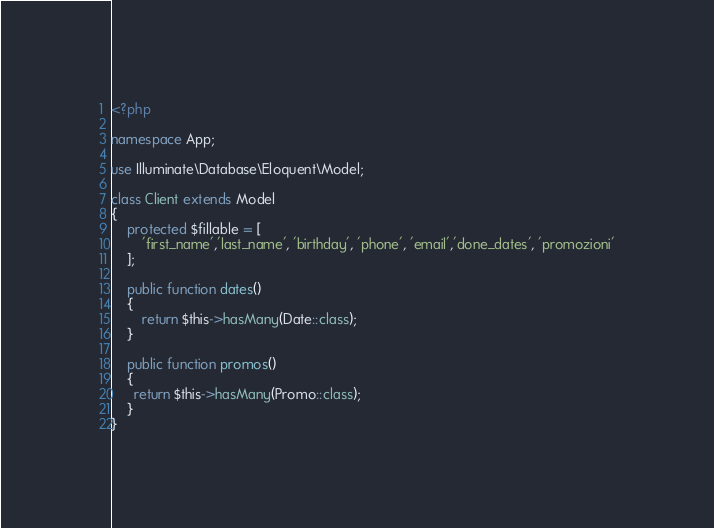Convert code to text. <code><loc_0><loc_0><loc_500><loc_500><_PHP_><?php

namespace App;

use Illuminate\Database\Eloquent\Model;

class Client extends Model
{
    protected $fillable = [
    	'first_name','last_name', 'birthday', 'phone', 'email','done_dates', 'promozioni'
    ];

    public function dates()
    {
    	return $this->hasMany(Date::class);
    }

    public function promos()
    {
      return $this->hasMany(Promo::class);
    }
}
</code> 